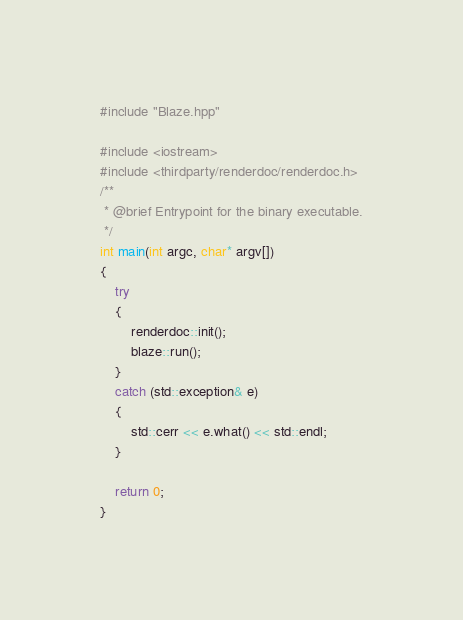<code> <loc_0><loc_0><loc_500><loc_500><_C++_>
#include "Blaze.hpp"

#include <iostream>
#include <thirdparty/renderdoc/renderdoc.h>
/**
 * @brief Entrypoint for the binary executable.
 */
int main(int argc, char* argv[])
{
	try
	{
		renderdoc::init();
		blaze::run();
	}
	catch (std::exception& e)
	{
		std::cerr << e.what() << std::endl;
	}

	return 0;
}</code> 